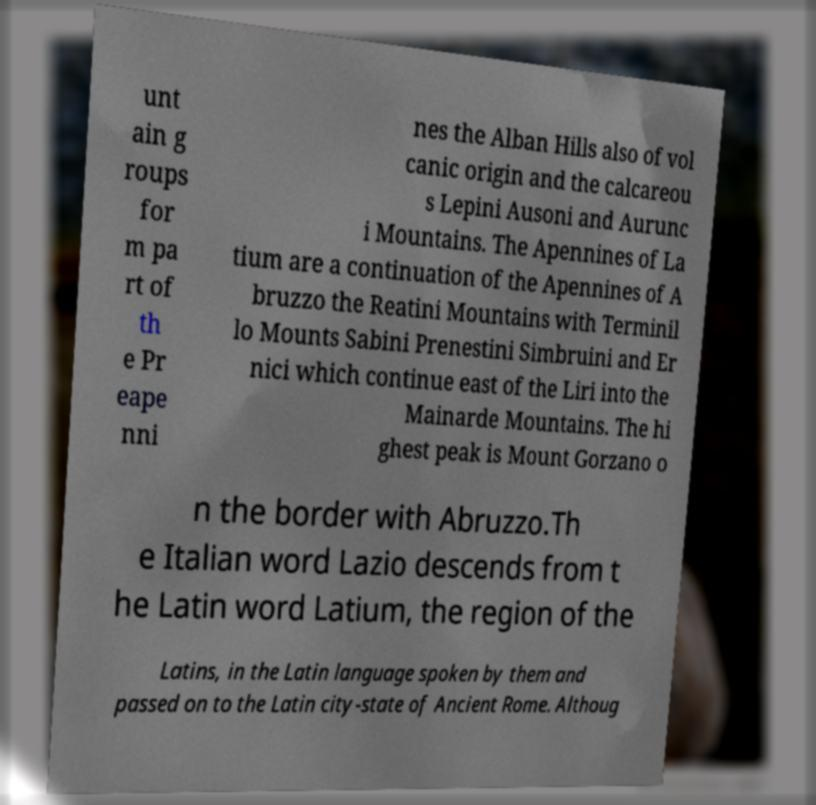I need the written content from this picture converted into text. Can you do that? unt ain g roups for m pa rt of th e Pr eape nni nes the Alban Hills also of vol canic origin and the calcareou s Lepini Ausoni and Aurunc i Mountains. The Apennines of La tium are a continuation of the Apennines of A bruzzo the Reatini Mountains with Terminil lo Mounts Sabini Prenestini Simbruini and Er nici which continue east of the Liri into the Mainarde Mountains. The hi ghest peak is Mount Gorzano o n the border with Abruzzo.Th e Italian word Lazio descends from t he Latin word Latium, the region of the Latins, in the Latin language spoken by them and passed on to the Latin city-state of Ancient Rome. Althoug 